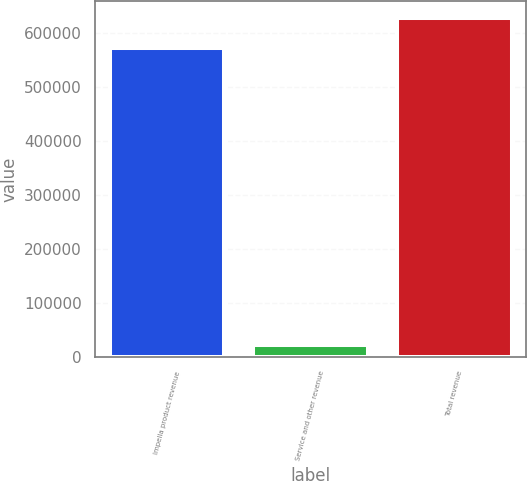Convert chart to OTSL. <chart><loc_0><loc_0><loc_500><loc_500><bar_chart><fcel>Impella product revenue<fcel>Service and other revenue<fcel>Total revenue<nl><fcel>570870<fcel>22879<fcel>627957<nl></chart> 